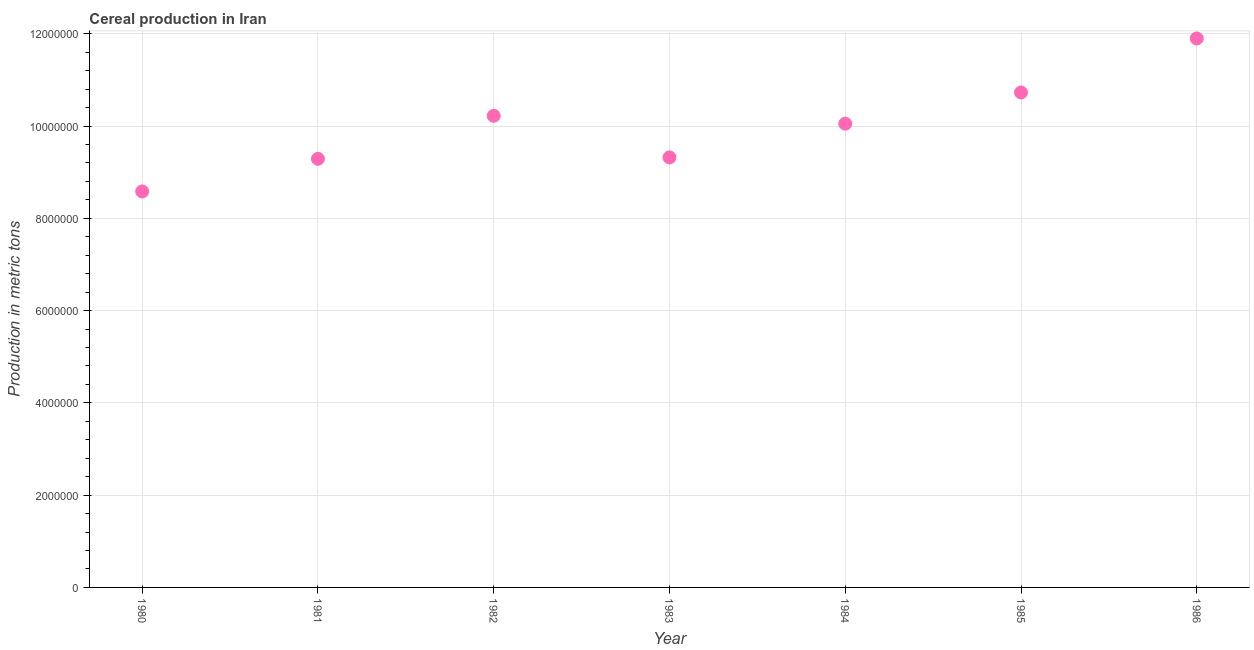What is the cereal production in 1981?
Keep it short and to the point. 9.29e+06. Across all years, what is the maximum cereal production?
Your answer should be compact. 1.19e+07. Across all years, what is the minimum cereal production?
Offer a terse response. 8.58e+06. In which year was the cereal production minimum?
Give a very brief answer. 1980. What is the sum of the cereal production?
Your answer should be compact. 7.01e+07. What is the difference between the cereal production in 1982 and 1986?
Offer a very short reply. -1.68e+06. What is the average cereal production per year?
Provide a short and direct response. 1.00e+07. What is the median cereal production?
Your response must be concise. 1.01e+07. Do a majority of the years between 1986 and 1982 (inclusive) have cereal production greater than 6000000 metric tons?
Make the answer very short. Yes. What is the ratio of the cereal production in 1985 to that in 1986?
Your response must be concise. 0.9. Is the difference between the cereal production in 1981 and 1982 greater than the difference between any two years?
Ensure brevity in your answer.  No. What is the difference between the highest and the second highest cereal production?
Keep it short and to the point. 1.17e+06. Is the sum of the cereal production in 1985 and 1986 greater than the maximum cereal production across all years?
Your response must be concise. Yes. What is the difference between the highest and the lowest cereal production?
Your answer should be compact. 3.32e+06. In how many years, is the cereal production greater than the average cereal production taken over all years?
Make the answer very short. 4. Does the cereal production monotonically increase over the years?
Provide a short and direct response. No. Are the values on the major ticks of Y-axis written in scientific E-notation?
Make the answer very short. No. Does the graph contain any zero values?
Give a very brief answer. No. What is the title of the graph?
Provide a short and direct response. Cereal production in Iran. What is the label or title of the Y-axis?
Make the answer very short. Production in metric tons. What is the Production in metric tons in 1980?
Make the answer very short. 8.58e+06. What is the Production in metric tons in 1981?
Your response must be concise. 9.29e+06. What is the Production in metric tons in 1982?
Your answer should be compact. 1.02e+07. What is the Production in metric tons in 1983?
Give a very brief answer. 9.32e+06. What is the Production in metric tons in 1984?
Offer a terse response. 1.01e+07. What is the Production in metric tons in 1985?
Ensure brevity in your answer.  1.07e+07. What is the Production in metric tons in 1986?
Make the answer very short. 1.19e+07. What is the difference between the Production in metric tons in 1980 and 1981?
Give a very brief answer. -7.07e+05. What is the difference between the Production in metric tons in 1980 and 1982?
Your response must be concise. -1.64e+06. What is the difference between the Production in metric tons in 1980 and 1983?
Provide a short and direct response. -7.38e+05. What is the difference between the Production in metric tons in 1980 and 1984?
Offer a terse response. -1.47e+06. What is the difference between the Production in metric tons in 1980 and 1985?
Offer a terse response. -2.14e+06. What is the difference between the Production in metric tons in 1980 and 1986?
Provide a succinct answer. -3.32e+06. What is the difference between the Production in metric tons in 1981 and 1982?
Offer a very short reply. -9.32e+05. What is the difference between the Production in metric tons in 1981 and 1983?
Keep it short and to the point. -3.15e+04. What is the difference between the Production in metric tons in 1981 and 1984?
Give a very brief answer. -7.62e+05. What is the difference between the Production in metric tons in 1981 and 1985?
Give a very brief answer. -1.44e+06. What is the difference between the Production in metric tons in 1981 and 1986?
Your response must be concise. -2.61e+06. What is the difference between the Production in metric tons in 1982 and 1983?
Provide a succinct answer. 9.00e+05. What is the difference between the Production in metric tons in 1982 and 1984?
Your answer should be compact. 1.70e+05. What is the difference between the Production in metric tons in 1982 and 1985?
Your response must be concise. -5.06e+05. What is the difference between the Production in metric tons in 1982 and 1986?
Your answer should be very brief. -1.68e+06. What is the difference between the Production in metric tons in 1983 and 1984?
Provide a succinct answer. -7.30e+05. What is the difference between the Production in metric tons in 1983 and 1985?
Your answer should be compact. -1.41e+06. What is the difference between the Production in metric tons in 1983 and 1986?
Your answer should be compact. -2.58e+06. What is the difference between the Production in metric tons in 1984 and 1985?
Your answer should be compact. -6.76e+05. What is the difference between the Production in metric tons in 1984 and 1986?
Give a very brief answer. -1.85e+06. What is the difference between the Production in metric tons in 1985 and 1986?
Provide a succinct answer. -1.17e+06. What is the ratio of the Production in metric tons in 1980 to that in 1981?
Your answer should be very brief. 0.92. What is the ratio of the Production in metric tons in 1980 to that in 1982?
Your response must be concise. 0.84. What is the ratio of the Production in metric tons in 1980 to that in 1983?
Your response must be concise. 0.92. What is the ratio of the Production in metric tons in 1980 to that in 1984?
Your answer should be very brief. 0.85. What is the ratio of the Production in metric tons in 1980 to that in 1986?
Your answer should be compact. 0.72. What is the ratio of the Production in metric tons in 1981 to that in 1982?
Give a very brief answer. 0.91. What is the ratio of the Production in metric tons in 1981 to that in 1983?
Offer a very short reply. 1. What is the ratio of the Production in metric tons in 1981 to that in 1984?
Give a very brief answer. 0.92. What is the ratio of the Production in metric tons in 1981 to that in 1985?
Offer a very short reply. 0.87. What is the ratio of the Production in metric tons in 1981 to that in 1986?
Offer a terse response. 0.78. What is the ratio of the Production in metric tons in 1982 to that in 1983?
Your answer should be compact. 1.1. What is the ratio of the Production in metric tons in 1982 to that in 1985?
Your answer should be compact. 0.95. What is the ratio of the Production in metric tons in 1982 to that in 1986?
Your answer should be very brief. 0.86. What is the ratio of the Production in metric tons in 1983 to that in 1984?
Offer a very short reply. 0.93. What is the ratio of the Production in metric tons in 1983 to that in 1985?
Keep it short and to the point. 0.87. What is the ratio of the Production in metric tons in 1983 to that in 1986?
Your answer should be compact. 0.78. What is the ratio of the Production in metric tons in 1984 to that in 1985?
Your answer should be compact. 0.94. What is the ratio of the Production in metric tons in 1984 to that in 1986?
Make the answer very short. 0.84. What is the ratio of the Production in metric tons in 1985 to that in 1986?
Ensure brevity in your answer.  0.9. 